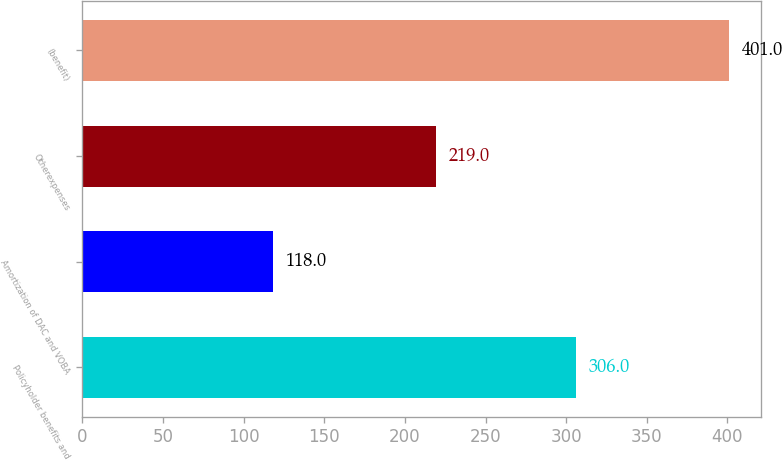Convert chart. <chart><loc_0><loc_0><loc_500><loc_500><bar_chart><fcel>Policyholder benefits and<fcel>Amortization of DAC and VOBA<fcel>Otherexpenses<fcel>(benefit)<nl><fcel>306<fcel>118<fcel>219<fcel>401<nl></chart> 